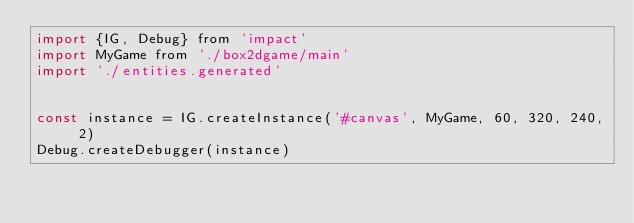<code> <loc_0><loc_0><loc_500><loc_500><_JavaScript_>import {IG, Debug} from 'impact'
import MyGame from './box2dgame/main'
import './entities.generated'


const instance = IG.createInstance('#canvas', MyGame, 60, 320, 240, 2)
Debug.createDebugger(instance)
</code> 